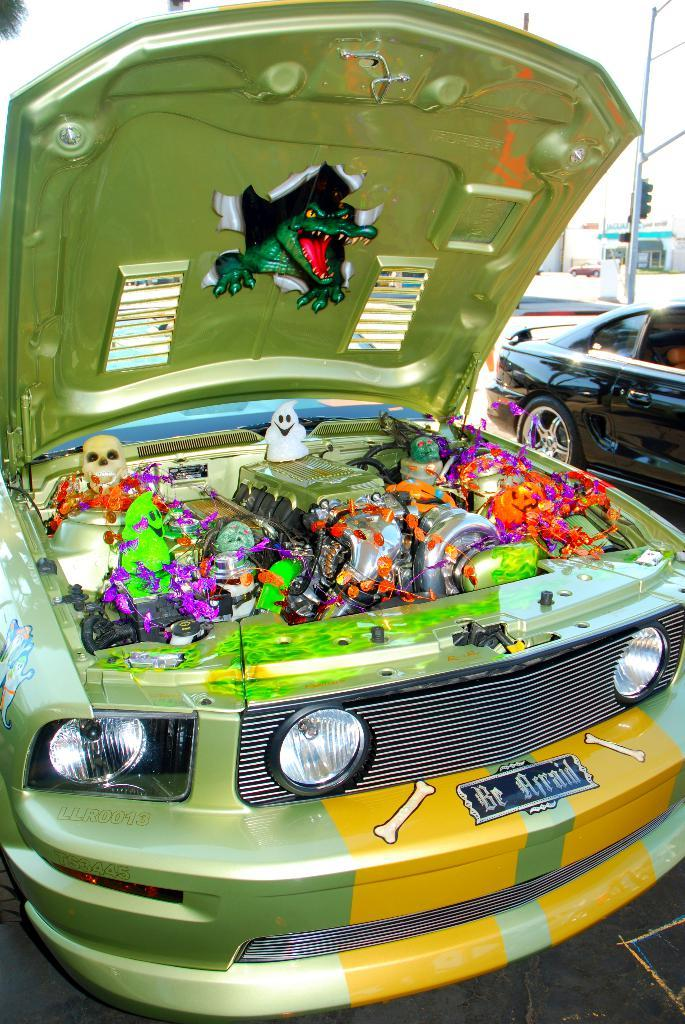What type of vehicles can be seen in the image? There are cars in the image. What can be seen in the distance behind the cars? There are buildings and a pole in the background of the image. What is the tendency of the steel in the image? There is no steel present in the image, so it is not possible to determine its tendency. 